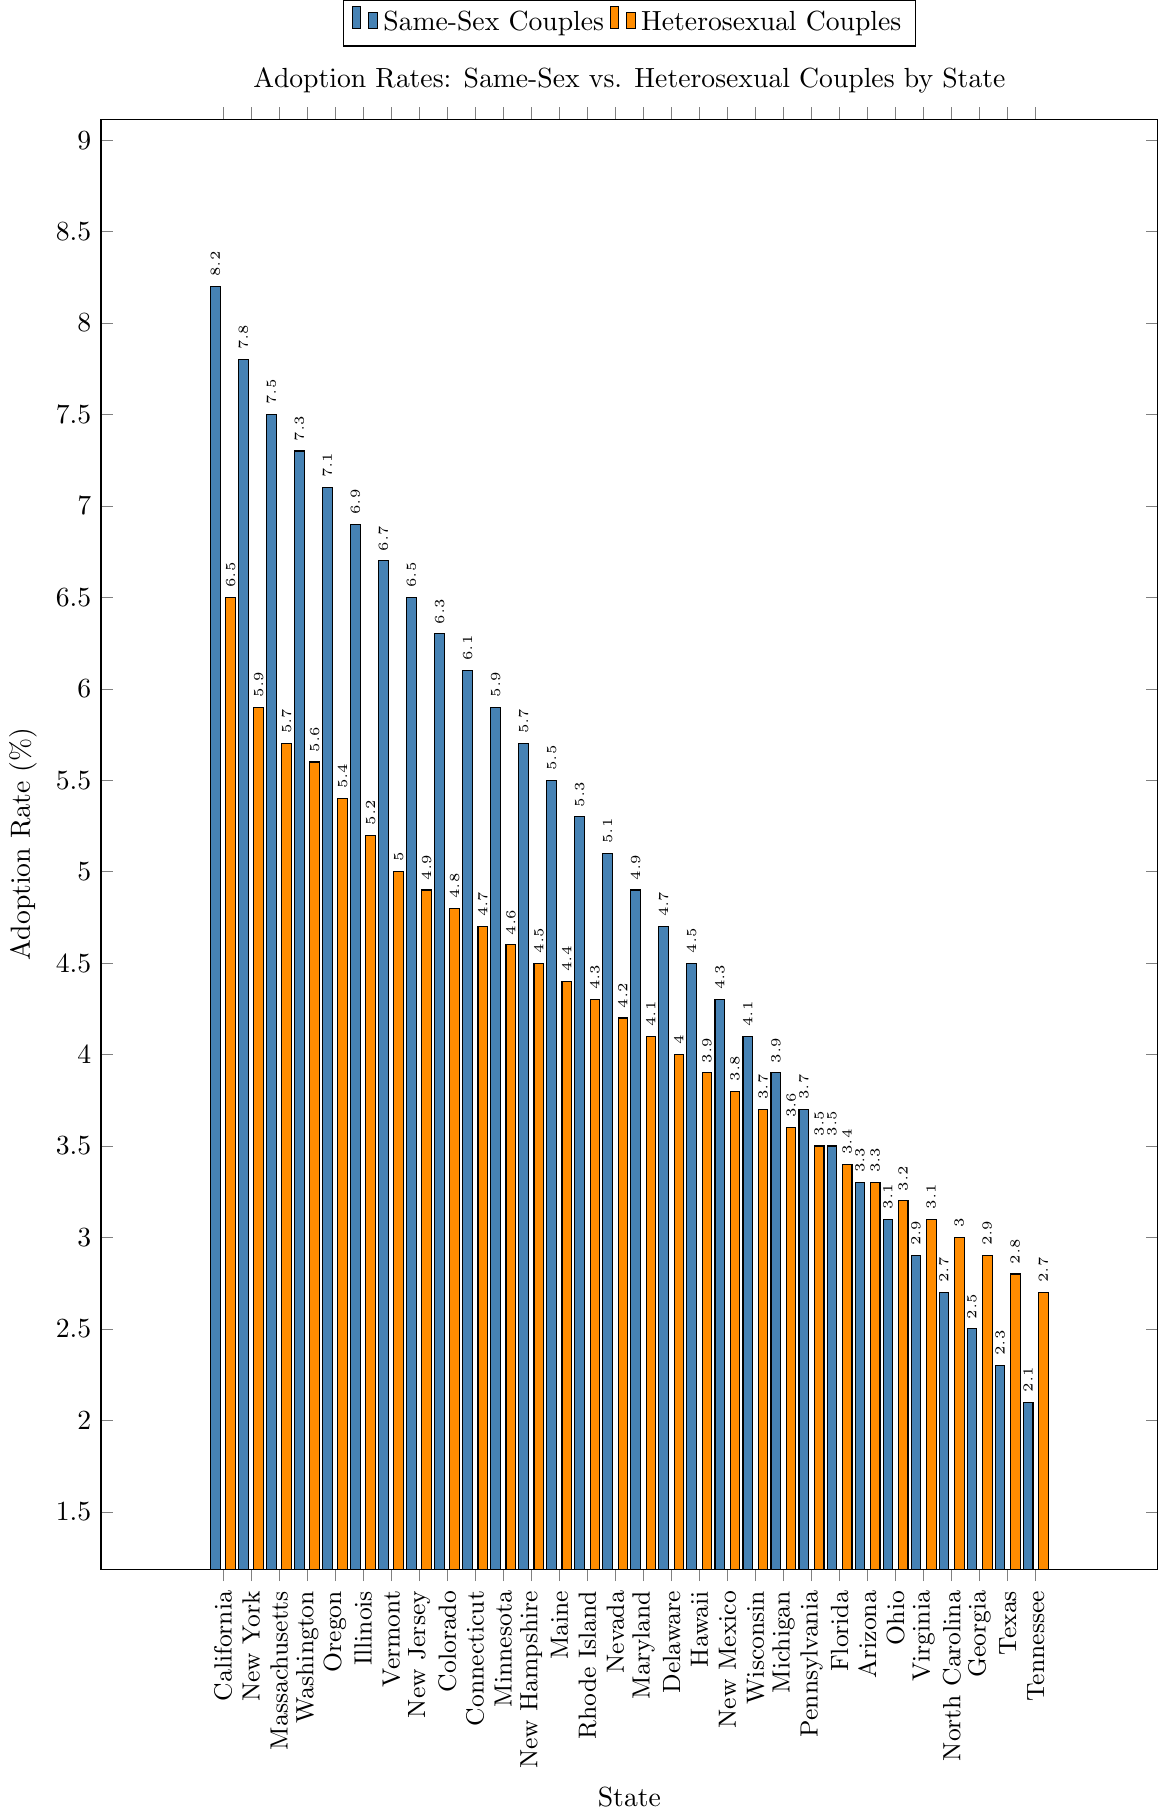What is the state with the highest adoption rate for same-sex couples, and what is the rate? First, identify the highest bar among same-sex couples. The highest bar for same-sex couples is in California with a rate of 8.2%.
Answer: California, 8.2% Which state has the smallest difference in adoption rates between same-sex couples and heterosexual couples? Calculate the absolute difference between the rates for same-sex and heterosexual couples for each state. The smallest difference is in Arizona, where the rates are both 3.3%, resulting in a difference of 0.0%.
Answer: Arizona, 0.0% What is the average adoption rate across all states for same-sex couples? To find the average, sum the adoption rates for same-sex couples in all states and divide by the total number of states. The total sum of same-sex couples' adoption rates is 127.1%, and there are 30 states, so the average is 127.1/30.
Answer: 4.24% In which states do same-sex couples have a higher adoption rate than heterosexual couples? Compare the adoption rates for each state side by side. If the bar for same-sex couples is higher than the bar for heterosexual couples, then same-sex couples have a higher adoption rate. This is true for all states in the data.
Answer: All States What is the state with the greatest difference in adoption rates between same-sex couples and heterosexual couples? Calculate the absolute difference between same-sex and heterosexual couples’ adoption rates for each state. The greatest difference is in California with a difference of 1.7% (8.2% - 6.5%).
Answer: California, 1.7% Which state has the second-highest adoption rate for heterosexual couples, and what is the rate? Identify the states and rates for heterosexual couples, then determine the second-highest rate. New York has the second-highest rate at 5.9%.
Answer: New York, 5.9% Among the states listed, which two states have the adoption rates closest to each other for same-sex couples? Calculate the differences between the adoption rates of same-sex couples for each adjacent state. The closest rates are in New Jersey and Vermont with a difference of 0.2% (6.7% - 6.5%).
Answer: New Jersey and Vermont, 0.2% What is the overall trend in adoption rates for same-sex vs. heterosexual couples as we move from California to Tennessee? Visually inspect the bars from left to right. Generally, adoption rates for same-sex couples start higher and gradually decrease, while heterosexual couples' rates are also decreasing but lower.
Answer: Decreasing trend for both Which states have a same-sex adoption rate of over 5%? Identify the states where the same-sex adoption rate bar is over 5%. The states are California, New York, Massachusetts, Washington, Oregon, Illinois, Vermont, New Jersey, Colorado, Connecticut, Minnesota, New Hampshire, and Maine.
Answer: 13 states 